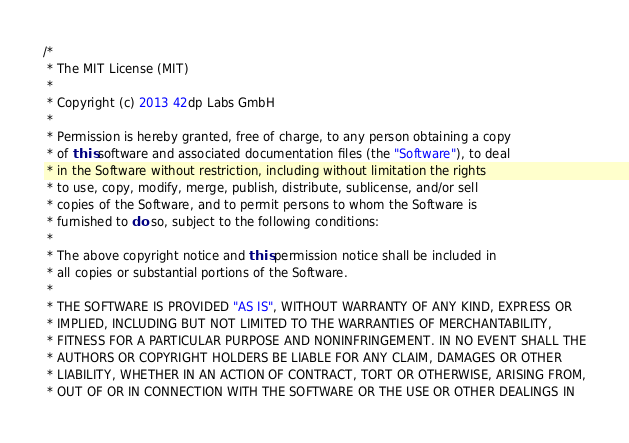Convert code to text. <code><loc_0><loc_0><loc_500><loc_500><_Java_>/*
 * The MIT License (MIT)
 *
 * Copyright (c) 2013 42dp Labs GmbH
 *
 * Permission is hereby granted, free of charge, to any person obtaining a copy
 * of this software and associated documentation files (the "Software"), to deal
 * in the Software without restriction, including without limitation the rights
 * to use, copy, modify, merge, publish, distribute, sublicense, and/or sell
 * copies of the Software, and to permit persons to whom the Software is
 * furnished to do so, subject to the following conditions:
 *
 * The above copyright notice and this permission notice shall be included in
 * all copies or substantial portions of the Software.
 *
 * THE SOFTWARE IS PROVIDED "AS IS", WITHOUT WARRANTY OF ANY KIND, EXPRESS OR
 * IMPLIED, INCLUDING BUT NOT LIMITED TO THE WARRANTIES OF MERCHANTABILITY,
 * FITNESS FOR A PARTICULAR PURPOSE AND NONINFRINGEMENT. IN NO EVENT SHALL THE
 * AUTHORS OR COPYRIGHT HOLDERS BE LIABLE FOR ANY CLAIM, DAMAGES OR OTHER
 * LIABILITY, WHETHER IN AN ACTION OF CONTRACT, TORT OR OTHERWISE, ARISING FROM,
 * OUT OF OR IN CONNECTION WITH THE SOFTWARE OR THE USE OR OTHER DEALINGS IN</code> 